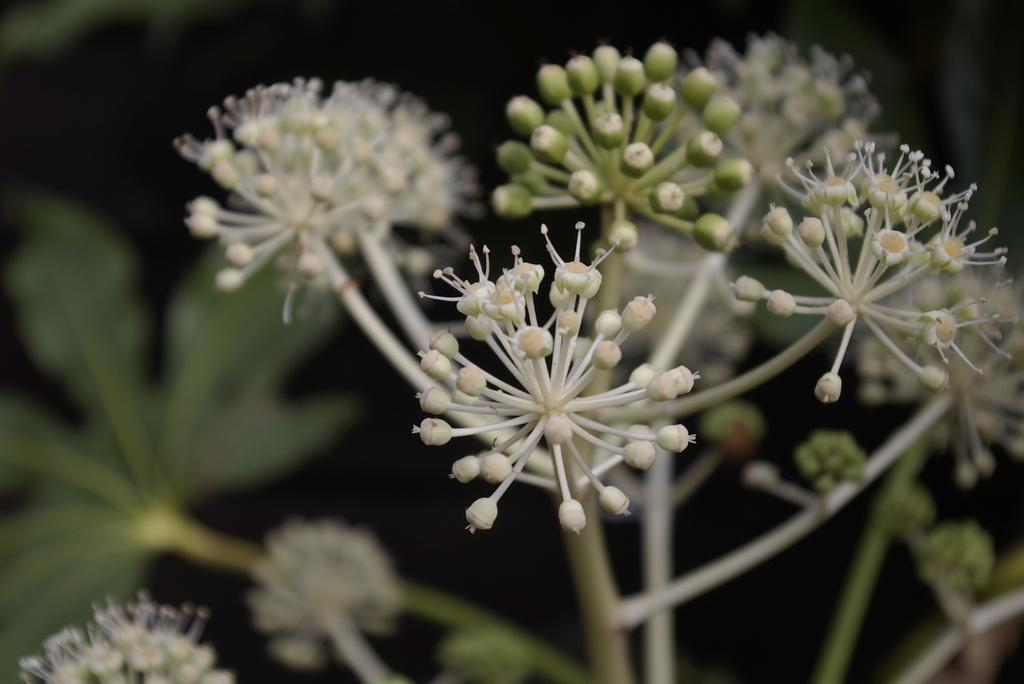What type of living organisms can be seen in the image? Plants can be seen in the image. What specific feature can be observed on the plants? The plants have flowers on them. What grade does the bat receive on its math test in the image? There is no bat or math test present in the image, so it is not possible to determine a grade. 